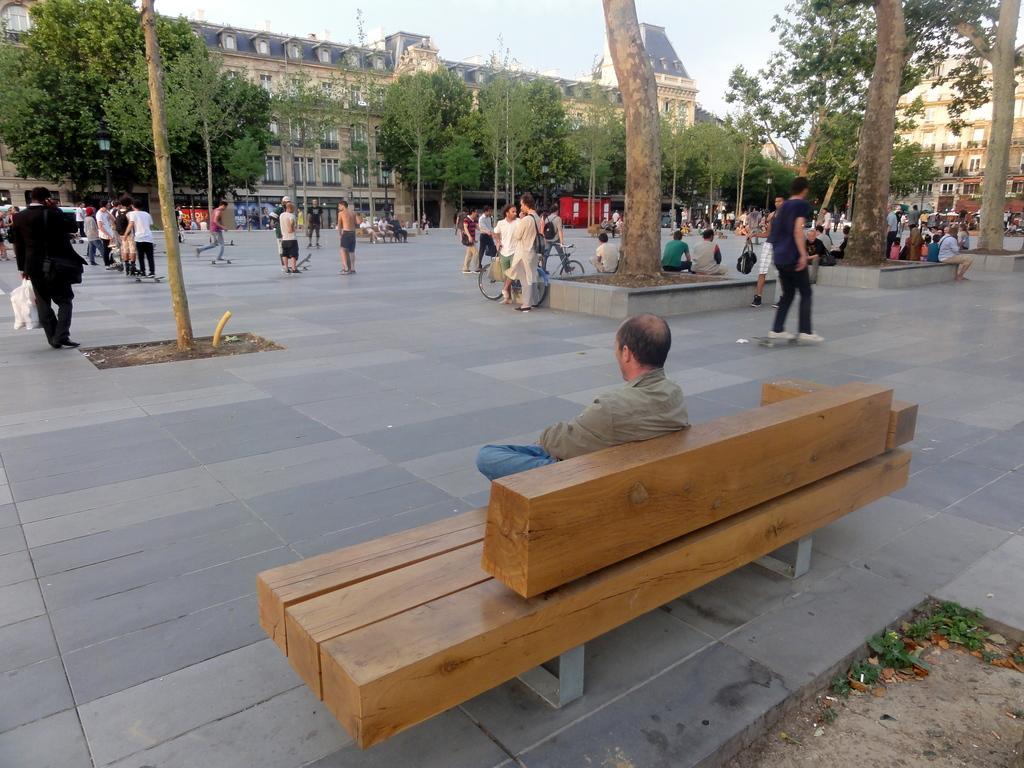Describe this image in one or two sentences. This image is clicked outside on the road. There are many people in this image. In the front, the man is sitting on the a bench. In the background, there are many trees and buildings. 